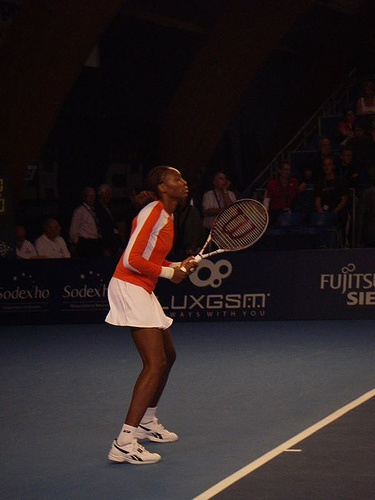Describe the objects in this image and their specific colors. I can see people in black, maroon, tan, and brown tones, tennis racket in black, maroon, and brown tones, people in black tones, people in black tones, and people in black tones in this image. 